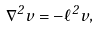<formula> <loc_0><loc_0><loc_500><loc_500>\nabla ^ { 2 } v = - \ell ^ { 2 } v ,</formula> 